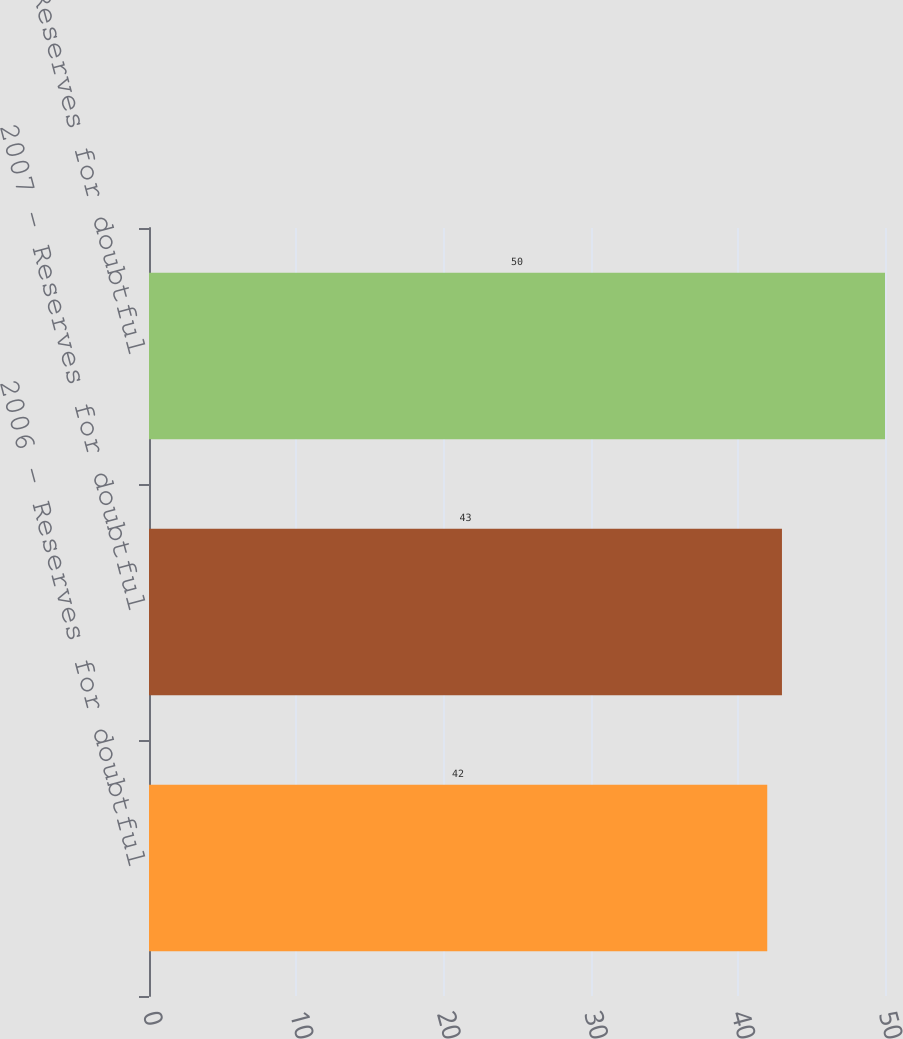Convert chart. <chart><loc_0><loc_0><loc_500><loc_500><bar_chart><fcel>2006 - Reserves for doubtful<fcel>2007 - Reserves for doubtful<fcel>2008 - Reserves for doubtful<nl><fcel>42<fcel>43<fcel>50<nl></chart> 